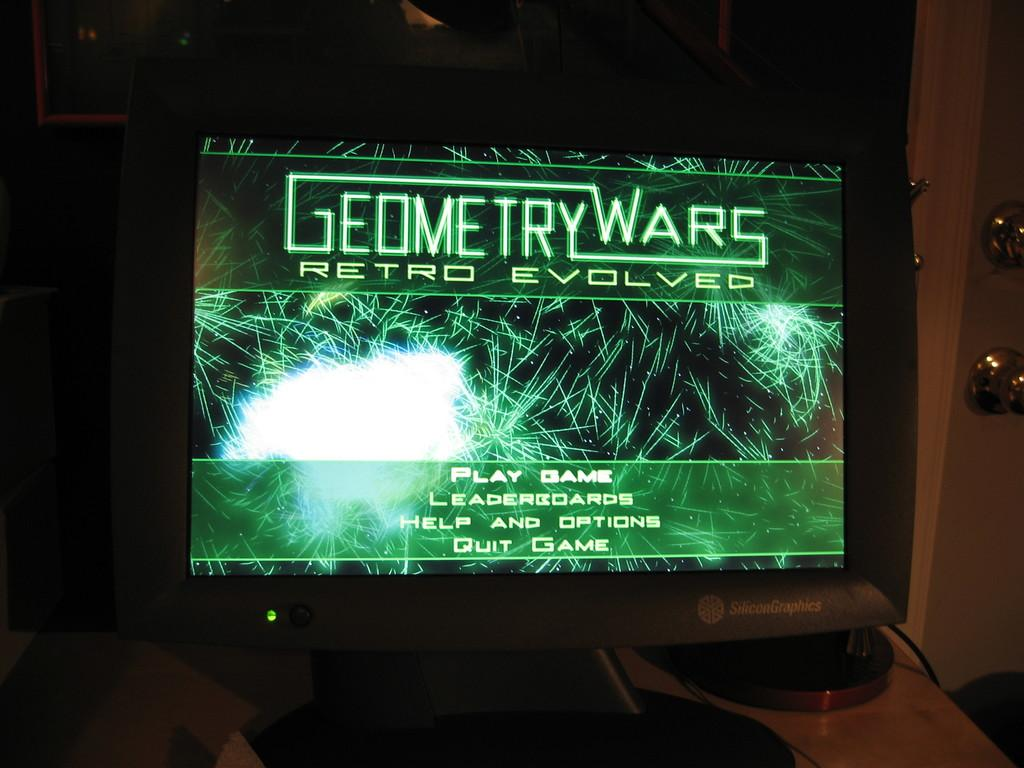<image>
Give a short and clear explanation of the subsequent image. Computer monitor showing a green screen for the game Geometry Wars. 